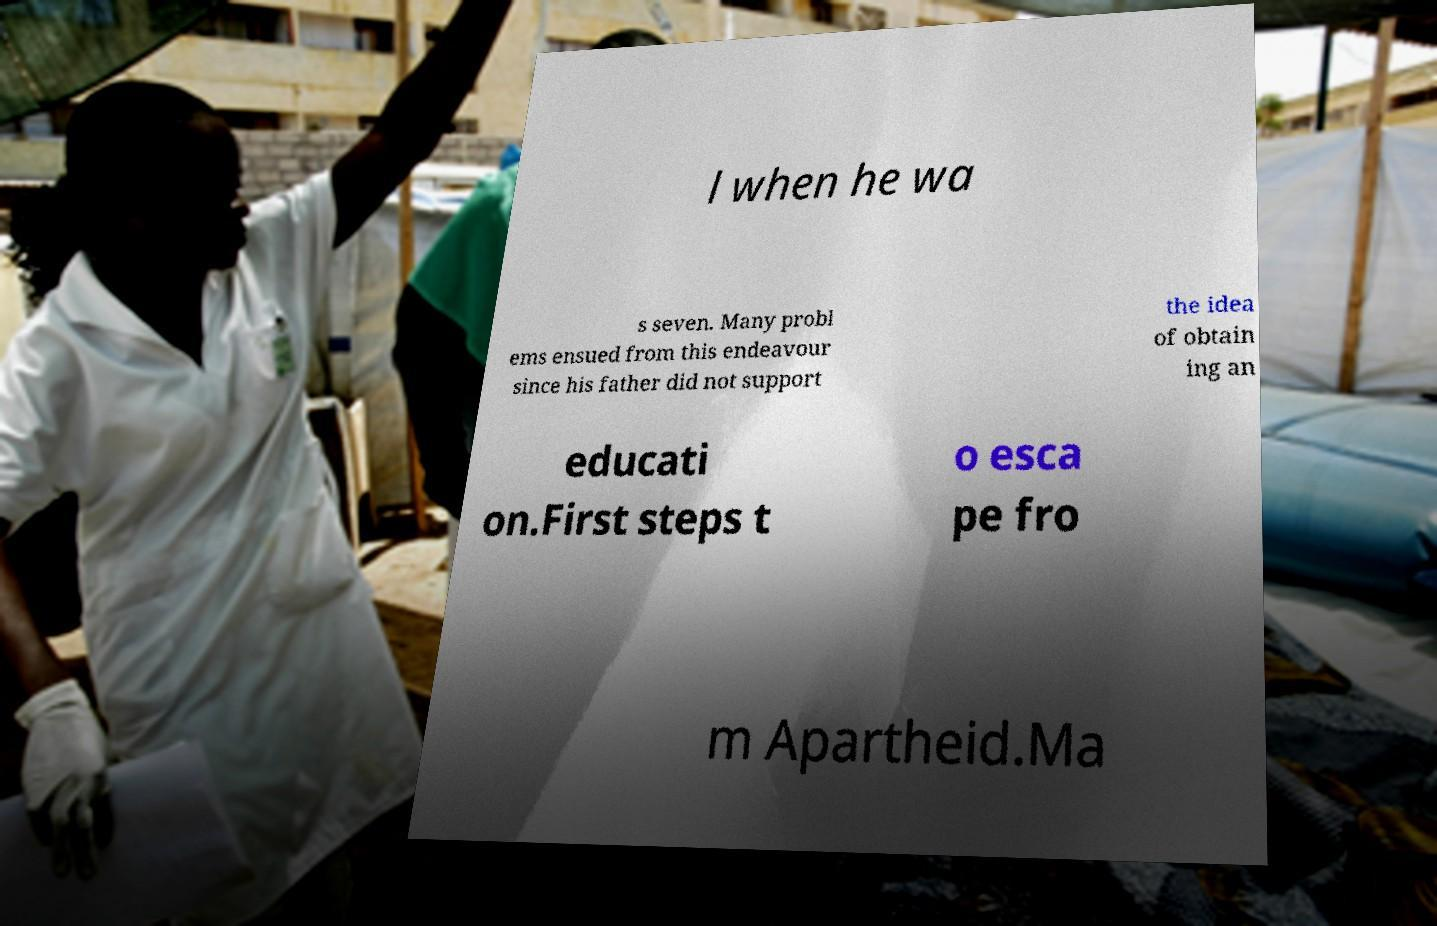Could you assist in decoding the text presented in this image and type it out clearly? l when he wa s seven. Many probl ems ensued from this endeavour since his father did not support the idea of obtain ing an educati on.First steps t o esca pe fro m Apartheid.Ma 